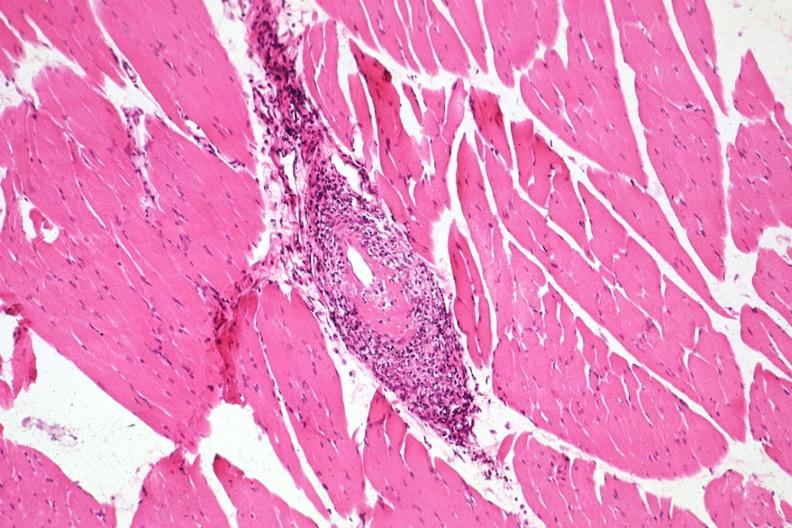s soft tissue present?
Answer the question using a single word or phrase. Yes 